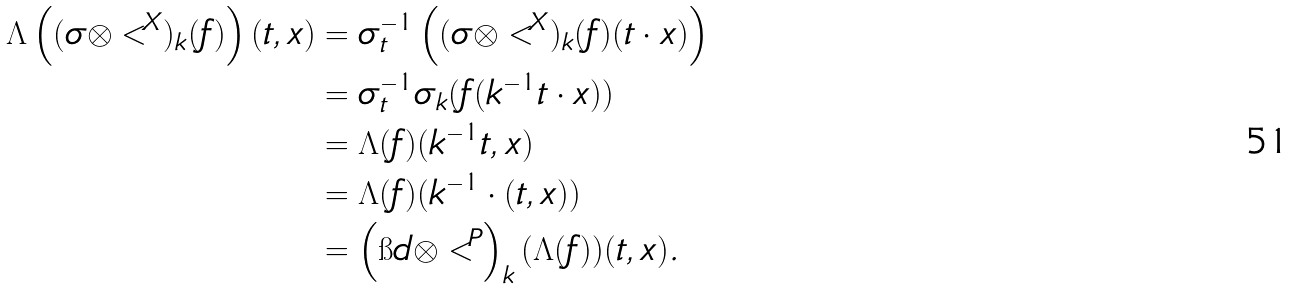<formula> <loc_0><loc_0><loc_500><loc_500>\Lambda \left ( ( \sigma \otimes < ^ { X } ) _ { k } ( f ) \right ) ( t , x ) & = \sigma _ { t } ^ { - 1 } \left ( ( \sigma \otimes < ^ { X } ) _ { k } ( f ) ( t \cdot x ) \right ) \\ & = \sigma _ { t } ^ { - 1 } \sigma _ { k } ( f ( k ^ { - 1 } t \cdot x ) ) \\ & = \Lambda ( f ) ( k ^ { - 1 } t , x ) \\ & = \Lambda ( f ) ( k ^ { - 1 } \cdot ( t , x ) ) \\ & = \left ( \i d \otimes < ^ { P } \right ) _ { k } ( \Lambda ( f ) ) ( t , x ) .</formula> 